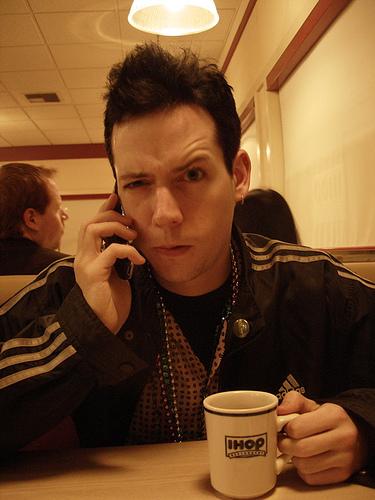Is this man right or left handed?
Be succinct. Left. What is the brand of the jacket?
Short answer required. Adidas. What is the person holding in his right hand (left side of picture)?
Keep it brief. Phone. What does the writing on the cup say?
Write a very short answer. Ihop. 